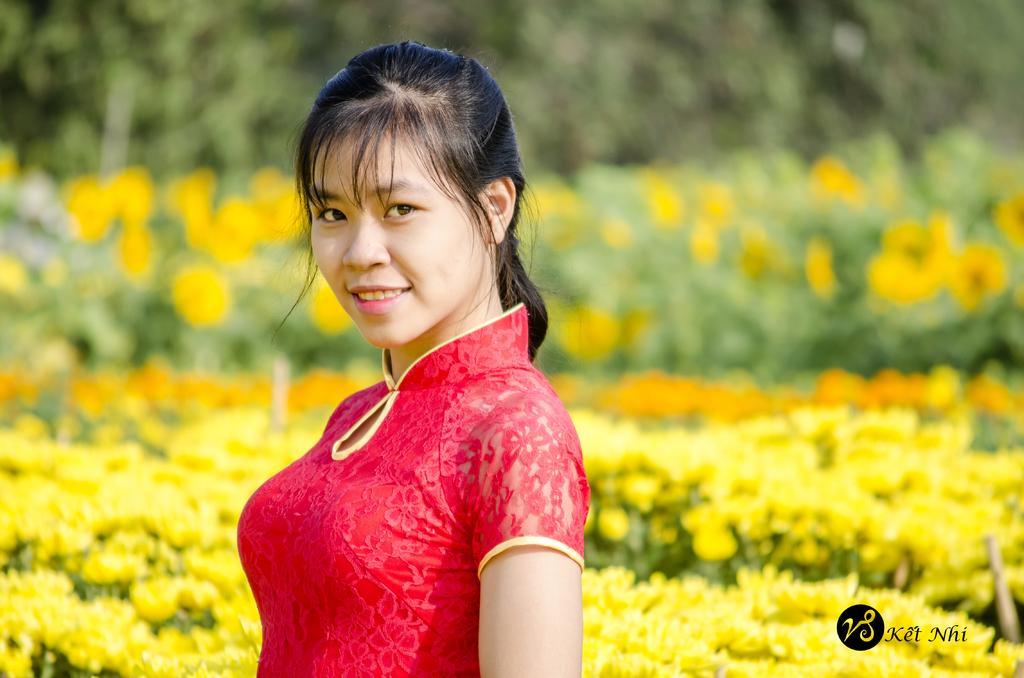In one or two sentences, can you explain what this image depicts? In the middle of the image a woman is standing and smiling. Behind her there are some flowers and plants. Background of the image is blur. 